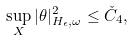Convert formula to latex. <formula><loc_0><loc_0><loc_500><loc_500>\sup _ { X } | \theta | _ { H _ { \epsilon } , \omega } ^ { 2 } \leq \check { C } _ { 4 } ,</formula> 